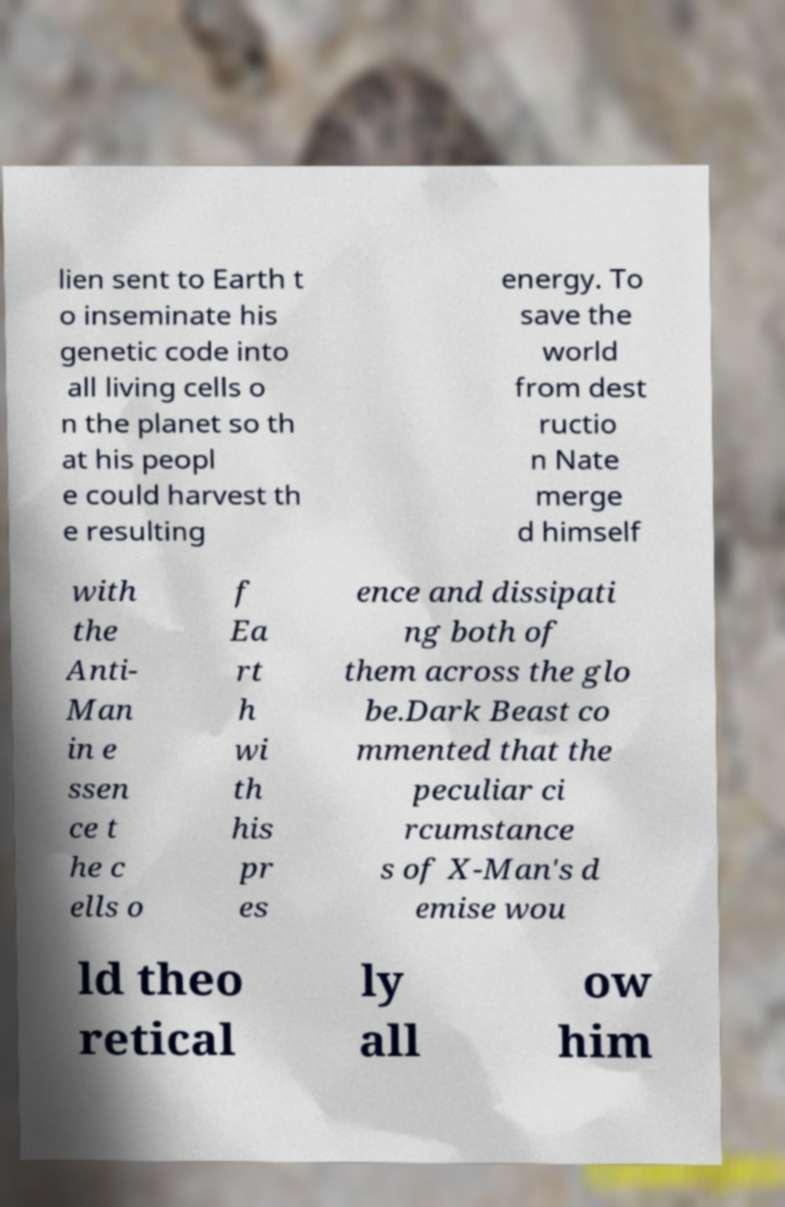What messages or text are displayed in this image? I need them in a readable, typed format. lien sent to Earth t o inseminate his genetic code into all living cells o n the planet so th at his peopl e could harvest th e resulting energy. To save the world from dest ructio n Nate merge d himself with the Anti- Man in e ssen ce t he c ells o f Ea rt h wi th his pr es ence and dissipati ng both of them across the glo be.Dark Beast co mmented that the peculiar ci rcumstance s of X-Man's d emise wou ld theo retical ly all ow him 